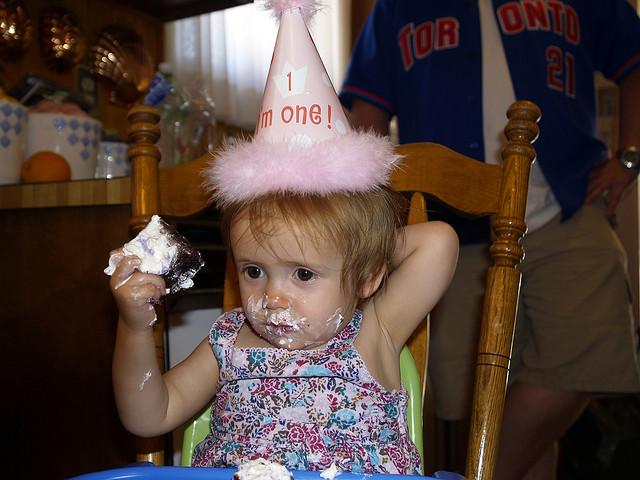Is the child smart?
Short answer required. Yes. What is the girl eating?
Concise answer only. Cake. What is the girl celebrating?
Be succinct. Birthday. Is there a hat on her head?
Keep it brief. Yes. 